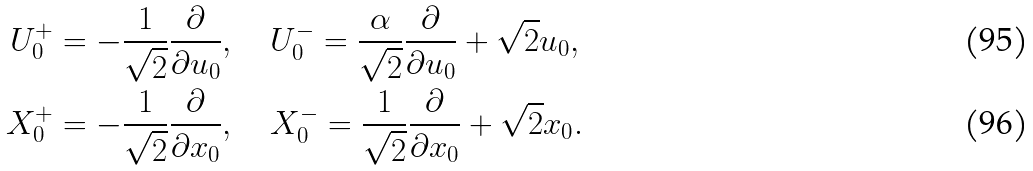Convert formula to latex. <formula><loc_0><loc_0><loc_500><loc_500>U _ { 0 } ^ { + } & = - \frac { 1 } { \sqrt { 2 } } \frac { \partial } { \partial u _ { 0 } } , \quad U _ { 0 } ^ { - } = \frac { \alpha } { \sqrt { 2 } } \frac { \partial } { \partial u _ { 0 } } + \sqrt { 2 } u _ { 0 } , \\ X _ { 0 } ^ { + } & = - \frac { 1 } { \sqrt { 2 } } \frac { \partial } { \partial x _ { 0 } } , \quad X _ { 0 } ^ { - } = \frac { 1 } { \sqrt { 2 } } \frac { \partial } { \partial x _ { 0 } } + \sqrt { 2 } x _ { 0 } .</formula> 